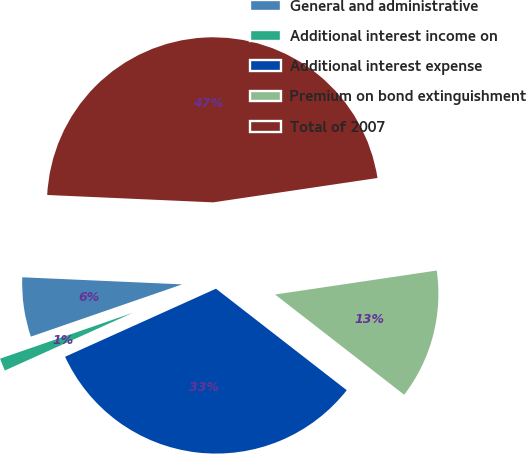Convert chart to OTSL. <chart><loc_0><loc_0><loc_500><loc_500><pie_chart><fcel>General and administrative<fcel>Additional interest income on<fcel>Additional interest expense<fcel>Premium on bond extinguishment<fcel>Total of 2007<nl><fcel>6.0%<fcel>1.45%<fcel>32.75%<fcel>12.85%<fcel>46.95%<nl></chart> 